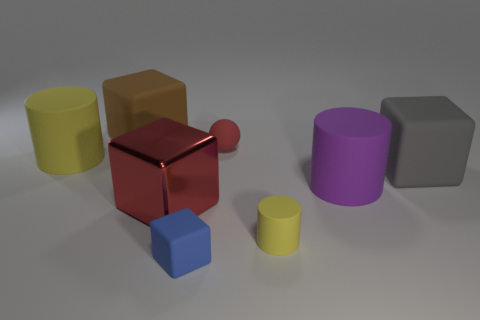Is there an object in the image that stands out due to its shininess, and what might that tell us about the material? Yes, there is an object that stands out because of its shininess: the red cube in the center of the image. Its reflective surface suggests that it could be made of a polished metal or a reflective plastic. The high gloss finish indicates the material is smooth and possibly treated to achieve such a reflective quality. This characteristic often signifies a material durable enough to maintain a shine, which is typical of metals or certain high-gloss plastics. 